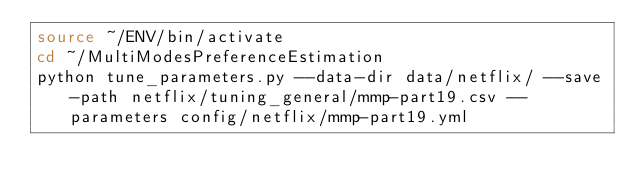<code> <loc_0><loc_0><loc_500><loc_500><_Bash_>source ~/ENV/bin/activate
cd ~/MultiModesPreferenceEstimation
python tune_parameters.py --data-dir data/netflix/ --save-path netflix/tuning_general/mmp-part19.csv --parameters config/netflix/mmp-part19.yml
</code> 